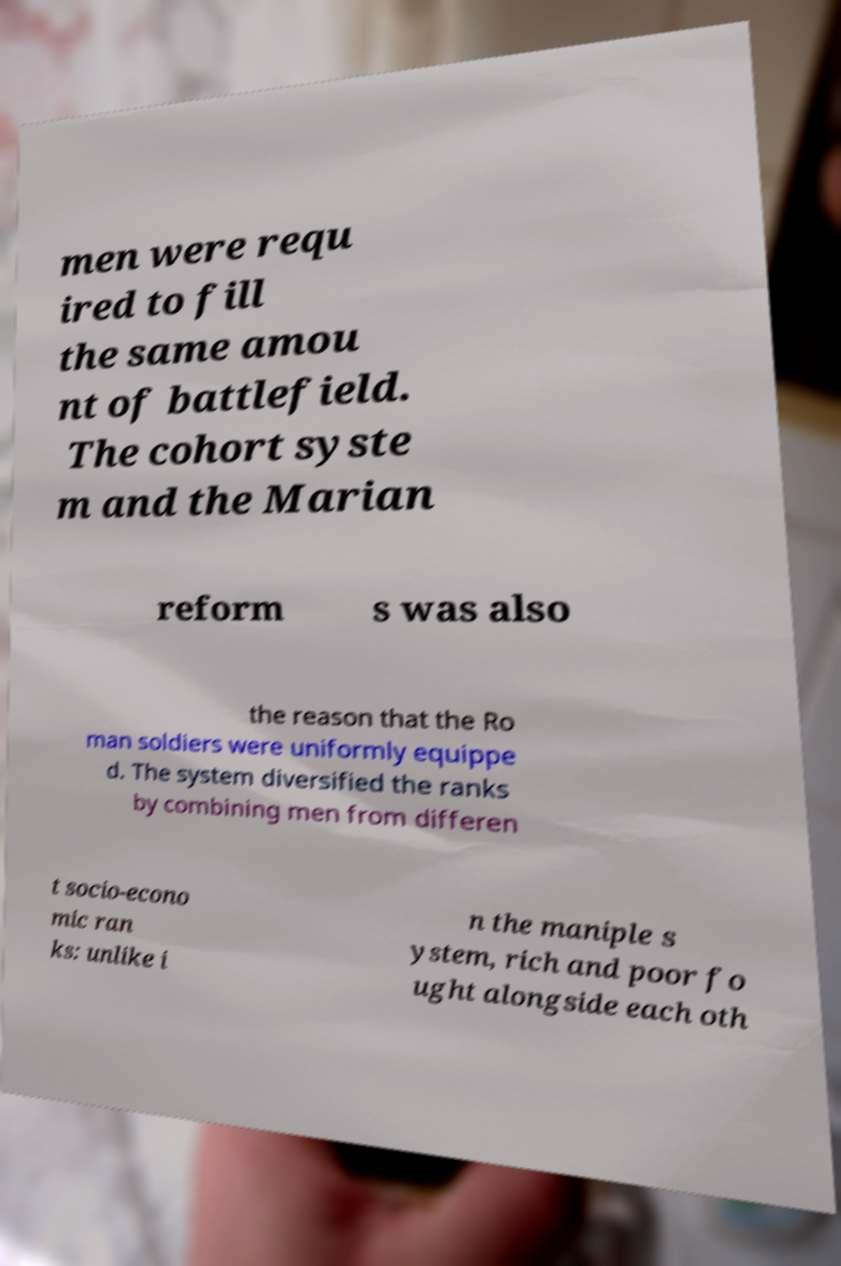Could you assist in decoding the text presented in this image and type it out clearly? men were requ ired to fill the same amou nt of battlefield. The cohort syste m and the Marian reform s was also the reason that the Ro man soldiers were uniformly equippe d. The system diversified the ranks by combining men from differen t socio-econo mic ran ks: unlike i n the maniple s ystem, rich and poor fo ught alongside each oth 